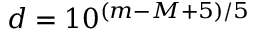Convert formula to latex. <formula><loc_0><loc_0><loc_500><loc_500>d = 1 0 ^ { ( m - M + 5 ) / 5 }</formula> 